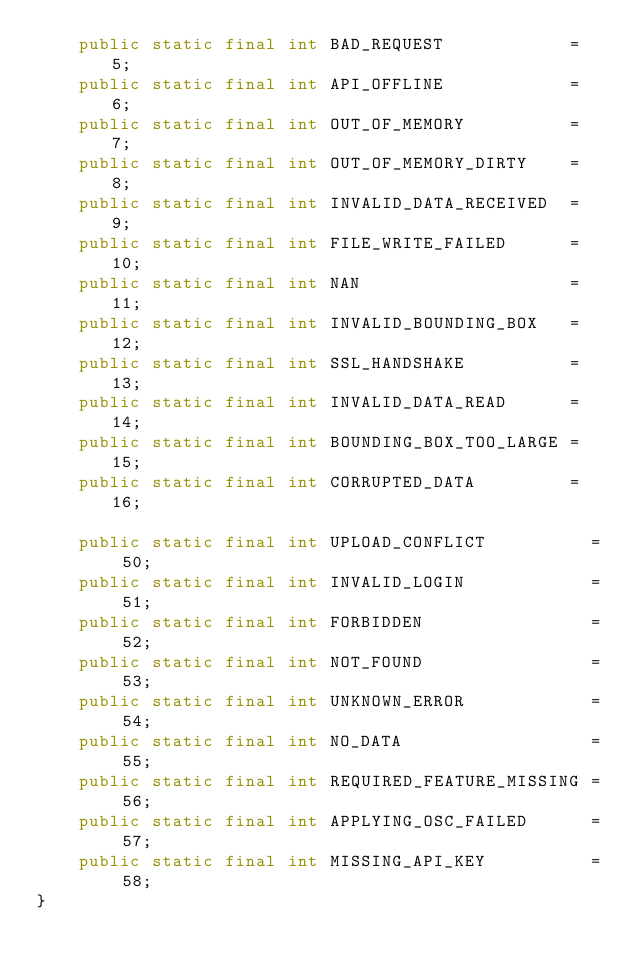Convert code to text. <code><loc_0><loc_0><loc_500><loc_500><_Java_>    public static final int BAD_REQUEST            = 5;
    public static final int API_OFFLINE            = 6;
    public static final int OUT_OF_MEMORY          = 7;
    public static final int OUT_OF_MEMORY_DIRTY    = 8;
    public static final int INVALID_DATA_RECEIVED  = 9;
    public static final int FILE_WRITE_FAILED      = 10;
    public static final int NAN                    = 11;
    public static final int INVALID_BOUNDING_BOX   = 12;
    public static final int SSL_HANDSHAKE          = 13;
    public static final int INVALID_DATA_READ      = 14;
    public static final int BOUNDING_BOX_TOO_LARGE = 15;
    public static final int CORRUPTED_DATA         = 16;

    public static final int UPLOAD_CONFLICT          = 50;
    public static final int INVALID_LOGIN            = 51;
    public static final int FORBIDDEN                = 52;
    public static final int NOT_FOUND                = 53;
    public static final int UNKNOWN_ERROR            = 54;
    public static final int NO_DATA                  = 55;
    public static final int REQUIRED_FEATURE_MISSING = 56;
    public static final int APPLYING_OSC_FAILED      = 57;
    public static final int MISSING_API_KEY          = 58;
}
</code> 